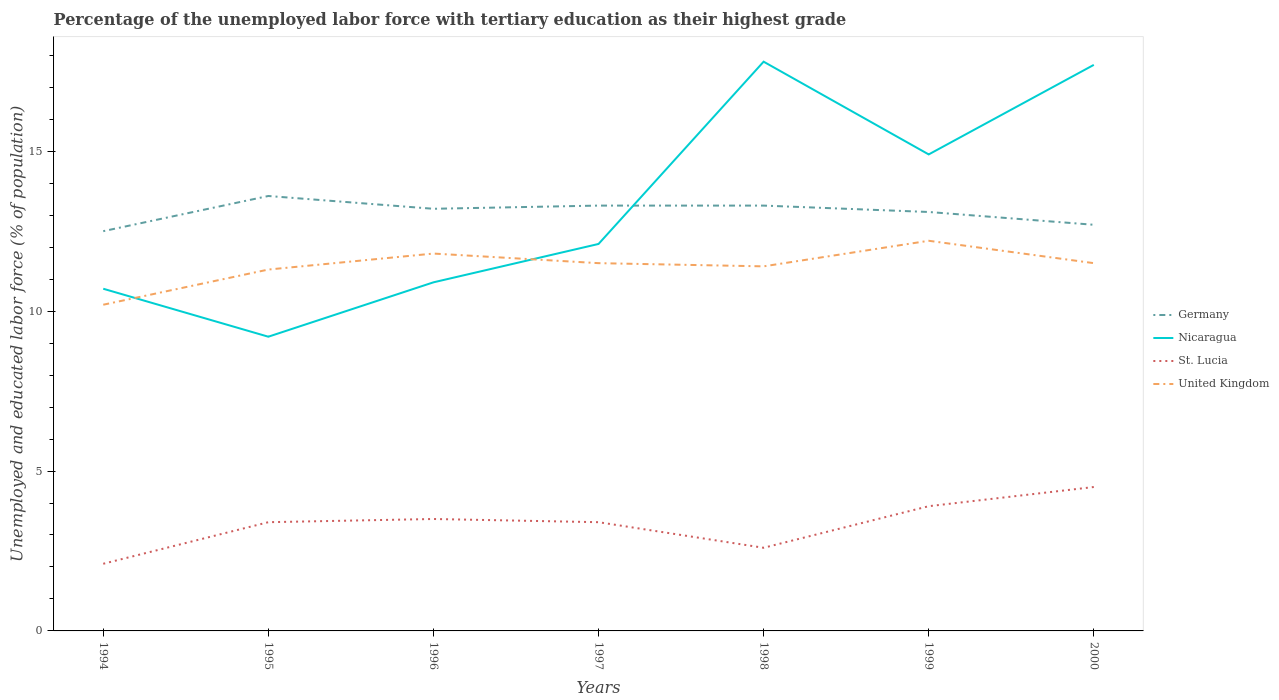Is the number of lines equal to the number of legend labels?
Your answer should be compact. Yes. Across all years, what is the maximum percentage of the unemployed labor force with tertiary education in St. Lucia?
Ensure brevity in your answer.  2.1. In which year was the percentage of the unemployed labor force with tertiary education in Germany maximum?
Your answer should be compact. 1994. What is the total percentage of the unemployed labor force with tertiary education in Nicaragua in the graph?
Give a very brief answer. -4.2. What is the difference between the highest and the second highest percentage of the unemployed labor force with tertiary education in Nicaragua?
Your response must be concise. 8.6. What is the difference between the highest and the lowest percentage of the unemployed labor force with tertiary education in St. Lucia?
Provide a succinct answer. 5. How many lines are there?
Your response must be concise. 4. What is the difference between two consecutive major ticks on the Y-axis?
Offer a very short reply. 5. Does the graph contain any zero values?
Your response must be concise. No. What is the title of the graph?
Make the answer very short. Percentage of the unemployed labor force with tertiary education as their highest grade. What is the label or title of the Y-axis?
Make the answer very short. Unemployed and educated labor force (% of population). What is the Unemployed and educated labor force (% of population) in Nicaragua in 1994?
Offer a very short reply. 10.7. What is the Unemployed and educated labor force (% of population) in St. Lucia in 1994?
Provide a succinct answer. 2.1. What is the Unemployed and educated labor force (% of population) of United Kingdom in 1994?
Provide a succinct answer. 10.2. What is the Unemployed and educated labor force (% of population) in Germany in 1995?
Keep it short and to the point. 13.6. What is the Unemployed and educated labor force (% of population) in Nicaragua in 1995?
Your response must be concise. 9.2. What is the Unemployed and educated labor force (% of population) in St. Lucia in 1995?
Make the answer very short. 3.4. What is the Unemployed and educated labor force (% of population) in United Kingdom in 1995?
Provide a succinct answer. 11.3. What is the Unemployed and educated labor force (% of population) of Germany in 1996?
Provide a succinct answer. 13.2. What is the Unemployed and educated labor force (% of population) of Nicaragua in 1996?
Your response must be concise. 10.9. What is the Unemployed and educated labor force (% of population) in United Kingdom in 1996?
Keep it short and to the point. 11.8. What is the Unemployed and educated labor force (% of population) of Germany in 1997?
Give a very brief answer. 13.3. What is the Unemployed and educated labor force (% of population) of Nicaragua in 1997?
Make the answer very short. 12.1. What is the Unemployed and educated labor force (% of population) of St. Lucia in 1997?
Your answer should be very brief. 3.4. What is the Unemployed and educated labor force (% of population) of United Kingdom in 1997?
Give a very brief answer. 11.5. What is the Unemployed and educated labor force (% of population) in Germany in 1998?
Offer a very short reply. 13.3. What is the Unemployed and educated labor force (% of population) in Nicaragua in 1998?
Provide a succinct answer. 17.8. What is the Unemployed and educated labor force (% of population) of St. Lucia in 1998?
Ensure brevity in your answer.  2.6. What is the Unemployed and educated labor force (% of population) in United Kingdom in 1998?
Ensure brevity in your answer.  11.4. What is the Unemployed and educated labor force (% of population) of Germany in 1999?
Provide a short and direct response. 13.1. What is the Unemployed and educated labor force (% of population) of Nicaragua in 1999?
Ensure brevity in your answer.  14.9. What is the Unemployed and educated labor force (% of population) in St. Lucia in 1999?
Give a very brief answer. 3.9. What is the Unemployed and educated labor force (% of population) of United Kingdom in 1999?
Your response must be concise. 12.2. What is the Unemployed and educated labor force (% of population) of Germany in 2000?
Your answer should be compact. 12.7. What is the Unemployed and educated labor force (% of population) of Nicaragua in 2000?
Offer a terse response. 17.7. What is the Unemployed and educated labor force (% of population) in St. Lucia in 2000?
Give a very brief answer. 4.5. Across all years, what is the maximum Unemployed and educated labor force (% of population) in Germany?
Your response must be concise. 13.6. Across all years, what is the maximum Unemployed and educated labor force (% of population) of Nicaragua?
Provide a succinct answer. 17.8. Across all years, what is the maximum Unemployed and educated labor force (% of population) in St. Lucia?
Ensure brevity in your answer.  4.5. Across all years, what is the maximum Unemployed and educated labor force (% of population) of United Kingdom?
Provide a succinct answer. 12.2. Across all years, what is the minimum Unemployed and educated labor force (% of population) in Germany?
Your answer should be very brief. 12.5. Across all years, what is the minimum Unemployed and educated labor force (% of population) in Nicaragua?
Make the answer very short. 9.2. Across all years, what is the minimum Unemployed and educated labor force (% of population) of St. Lucia?
Your answer should be compact. 2.1. Across all years, what is the minimum Unemployed and educated labor force (% of population) in United Kingdom?
Make the answer very short. 10.2. What is the total Unemployed and educated labor force (% of population) of Germany in the graph?
Offer a very short reply. 91.7. What is the total Unemployed and educated labor force (% of population) in Nicaragua in the graph?
Your answer should be compact. 93.3. What is the total Unemployed and educated labor force (% of population) in St. Lucia in the graph?
Ensure brevity in your answer.  23.4. What is the total Unemployed and educated labor force (% of population) of United Kingdom in the graph?
Your response must be concise. 79.9. What is the difference between the Unemployed and educated labor force (% of population) in Germany in 1994 and that in 1995?
Your answer should be very brief. -1.1. What is the difference between the Unemployed and educated labor force (% of population) of Germany in 1994 and that in 1996?
Your answer should be very brief. -0.7. What is the difference between the Unemployed and educated labor force (% of population) in St. Lucia in 1994 and that in 1996?
Your answer should be very brief. -1.4. What is the difference between the Unemployed and educated labor force (% of population) of United Kingdom in 1994 and that in 1996?
Your response must be concise. -1.6. What is the difference between the Unemployed and educated labor force (% of population) of Nicaragua in 1994 and that in 1998?
Your answer should be compact. -7.1. What is the difference between the Unemployed and educated labor force (% of population) in St. Lucia in 1994 and that in 1999?
Keep it short and to the point. -1.8. What is the difference between the Unemployed and educated labor force (% of population) of United Kingdom in 1994 and that in 1999?
Ensure brevity in your answer.  -2. What is the difference between the Unemployed and educated labor force (% of population) of Nicaragua in 1994 and that in 2000?
Give a very brief answer. -7. What is the difference between the Unemployed and educated labor force (% of population) in St. Lucia in 1994 and that in 2000?
Your answer should be compact. -2.4. What is the difference between the Unemployed and educated labor force (% of population) in Germany in 1995 and that in 1997?
Provide a succinct answer. 0.3. What is the difference between the Unemployed and educated labor force (% of population) in Nicaragua in 1995 and that in 1997?
Offer a terse response. -2.9. What is the difference between the Unemployed and educated labor force (% of population) in United Kingdom in 1995 and that in 1997?
Your response must be concise. -0.2. What is the difference between the Unemployed and educated labor force (% of population) in Nicaragua in 1995 and that in 1998?
Your answer should be very brief. -8.6. What is the difference between the Unemployed and educated labor force (% of population) of United Kingdom in 1995 and that in 1998?
Ensure brevity in your answer.  -0.1. What is the difference between the Unemployed and educated labor force (% of population) in United Kingdom in 1995 and that in 1999?
Offer a terse response. -0.9. What is the difference between the Unemployed and educated labor force (% of population) of Germany in 1995 and that in 2000?
Ensure brevity in your answer.  0.9. What is the difference between the Unemployed and educated labor force (% of population) in Nicaragua in 1995 and that in 2000?
Offer a very short reply. -8.5. What is the difference between the Unemployed and educated labor force (% of population) of St. Lucia in 1995 and that in 2000?
Your answer should be very brief. -1.1. What is the difference between the Unemployed and educated labor force (% of population) of St. Lucia in 1996 and that in 1997?
Make the answer very short. 0.1. What is the difference between the Unemployed and educated labor force (% of population) of Nicaragua in 1996 and that in 1998?
Keep it short and to the point. -6.9. What is the difference between the Unemployed and educated labor force (% of population) in United Kingdom in 1996 and that in 1998?
Provide a succinct answer. 0.4. What is the difference between the Unemployed and educated labor force (% of population) in Germany in 1996 and that in 1999?
Ensure brevity in your answer.  0.1. What is the difference between the Unemployed and educated labor force (% of population) in Nicaragua in 1996 and that in 1999?
Your response must be concise. -4. What is the difference between the Unemployed and educated labor force (% of population) of United Kingdom in 1996 and that in 1999?
Your answer should be very brief. -0.4. What is the difference between the Unemployed and educated labor force (% of population) in Germany in 1996 and that in 2000?
Provide a succinct answer. 0.5. What is the difference between the Unemployed and educated labor force (% of population) of Nicaragua in 1996 and that in 2000?
Make the answer very short. -6.8. What is the difference between the Unemployed and educated labor force (% of population) of St. Lucia in 1997 and that in 1998?
Your answer should be compact. 0.8. What is the difference between the Unemployed and educated labor force (% of population) of Germany in 1997 and that in 1999?
Your answer should be compact. 0.2. What is the difference between the Unemployed and educated labor force (% of population) of Nicaragua in 1997 and that in 1999?
Provide a succinct answer. -2.8. What is the difference between the Unemployed and educated labor force (% of population) in St. Lucia in 1997 and that in 1999?
Give a very brief answer. -0.5. What is the difference between the Unemployed and educated labor force (% of population) in Germany in 1997 and that in 2000?
Make the answer very short. 0.6. What is the difference between the Unemployed and educated labor force (% of population) of Nicaragua in 1997 and that in 2000?
Your answer should be very brief. -5.6. What is the difference between the Unemployed and educated labor force (% of population) in Nicaragua in 1998 and that in 1999?
Provide a succinct answer. 2.9. What is the difference between the Unemployed and educated labor force (% of population) in United Kingdom in 1998 and that in 1999?
Your response must be concise. -0.8. What is the difference between the Unemployed and educated labor force (% of population) in Germany in 1998 and that in 2000?
Offer a very short reply. 0.6. What is the difference between the Unemployed and educated labor force (% of population) in St. Lucia in 1998 and that in 2000?
Ensure brevity in your answer.  -1.9. What is the difference between the Unemployed and educated labor force (% of population) of Nicaragua in 1999 and that in 2000?
Your response must be concise. -2.8. What is the difference between the Unemployed and educated labor force (% of population) in St. Lucia in 1999 and that in 2000?
Offer a terse response. -0.6. What is the difference between the Unemployed and educated labor force (% of population) of United Kingdom in 1999 and that in 2000?
Your answer should be compact. 0.7. What is the difference between the Unemployed and educated labor force (% of population) in Germany in 1994 and the Unemployed and educated labor force (% of population) in Nicaragua in 1995?
Provide a succinct answer. 3.3. What is the difference between the Unemployed and educated labor force (% of population) in Germany in 1994 and the Unemployed and educated labor force (% of population) in St. Lucia in 1995?
Ensure brevity in your answer.  9.1. What is the difference between the Unemployed and educated labor force (% of population) of Nicaragua in 1994 and the Unemployed and educated labor force (% of population) of St. Lucia in 1995?
Make the answer very short. 7.3. What is the difference between the Unemployed and educated labor force (% of population) in Nicaragua in 1994 and the Unemployed and educated labor force (% of population) in United Kingdom in 1995?
Offer a terse response. -0.6. What is the difference between the Unemployed and educated labor force (% of population) in St. Lucia in 1994 and the Unemployed and educated labor force (% of population) in United Kingdom in 1995?
Ensure brevity in your answer.  -9.2. What is the difference between the Unemployed and educated labor force (% of population) of Germany in 1994 and the Unemployed and educated labor force (% of population) of Nicaragua in 1996?
Keep it short and to the point. 1.6. What is the difference between the Unemployed and educated labor force (% of population) in Germany in 1994 and the Unemployed and educated labor force (% of population) in St. Lucia in 1996?
Keep it short and to the point. 9. What is the difference between the Unemployed and educated labor force (% of population) in Nicaragua in 1994 and the Unemployed and educated labor force (% of population) in United Kingdom in 1996?
Your answer should be very brief. -1.1. What is the difference between the Unemployed and educated labor force (% of population) of Germany in 1994 and the Unemployed and educated labor force (% of population) of Nicaragua in 1997?
Provide a succinct answer. 0.4. What is the difference between the Unemployed and educated labor force (% of population) in Germany in 1994 and the Unemployed and educated labor force (% of population) in St. Lucia in 1997?
Offer a terse response. 9.1. What is the difference between the Unemployed and educated labor force (% of population) of Germany in 1994 and the Unemployed and educated labor force (% of population) of United Kingdom in 1997?
Your answer should be compact. 1. What is the difference between the Unemployed and educated labor force (% of population) of Nicaragua in 1994 and the Unemployed and educated labor force (% of population) of St. Lucia in 1997?
Your answer should be very brief. 7.3. What is the difference between the Unemployed and educated labor force (% of population) in Germany in 1994 and the Unemployed and educated labor force (% of population) in Nicaragua in 1998?
Your answer should be compact. -5.3. What is the difference between the Unemployed and educated labor force (% of population) of Germany in 1994 and the Unemployed and educated labor force (% of population) of St. Lucia in 1998?
Offer a terse response. 9.9. What is the difference between the Unemployed and educated labor force (% of population) in Nicaragua in 1994 and the Unemployed and educated labor force (% of population) in St. Lucia in 1998?
Ensure brevity in your answer.  8.1. What is the difference between the Unemployed and educated labor force (% of population) in Germany in 1994 and the Unemployed and educated labor force (% of population) in United Kingdom in 1999?
Provide a succinct answer. 0.3. What is the difference between the Unemployed and educated labor force (% of population) in Germany in 1994 and the Unemployed and educated labor force (% of population) in Nicaragua in 2000?
Your response must be concise. -5.2. What is the difference between the Unemployed and educated labor force (% of population) in Germany in 1994 and the Unemployed and educated labor force (% of population) in St. Lucia in 2000?
Ensure brevity in your answer.  8. What is the difference between the Unemployed and educated labor force (% of population) in Nicaragua in 1994 and the Unemployed and educated labor force (% of population) in St. Lucia in 2000?
Your answer should be compact. 6.2. What is the difference between the Unemployed and educated labor force (% of population) in Germany in 1995 and the Unemployed and educated labor force (% of population) in St. Lucia in 1996?
Your answer should be compact. 10.1. What is the difference between the Unemployed and educated labor force (% of population) in Germany in 1995 and the Unemployed and educated labor force (% of population) in United Kingdom in 1996?
Your response must be concise. 1.8. What is the difference between the Unemployed and educated labor force (% of population) of Nicaragua in 1995 and the Unemployed and educated labor force (% of population) of St. Lucia in 1996?
Provide a short and direct response. 5.7. What is the difference between the Unemployed and educated labor force (% of population) of Nicaragua in 1995 and the Unemployed and educated labor force (% of population) of United Kingdom in 1996?
Ensure brevity in your answer.  -2.6. What is the difference between the Unemployed and educated labor force (% of population) in Germany in 1995 and the Unemployed and educated labor force (% of population) in Nicaragua in 1997?
Keep it short and to the point. 1.5. What is the difference between the Unemployed and educated labor force (% of population) in Germany in 1995 and the Unemployed and educated labor force (% of population) in St. Lucia in 1997?
Ensure brevity in your answer.  10.2. What is the difference between the Unemployed and educated labor force (% of population) of Germany in 1995 and the Unemployed and educated labor force (% of population) of United Kingdom in 1997?
Provide a short and direct response. 2.1. What is the difference between the Unemployed and educated labor force (% of population) in Nicaragua in 1995 and the Unemployed and educated labor force (% of population) in St. Lucia in 1997?
Make the answer very short. 5.8. What is the difference between the Unemployed and educated labor force (% of population) in St. Lucia in 1995 and the Unemployed and educated labor force (% of population) in United Kingdom in 1997?
Make the answer very short. -8.1. What is the difference between the Unemployed and educated labor force (% of population) in Germany in 1995 and the Unemployed and educated labor force (% of population) in United Kingdom in 1998?
Keep it short and to the point. 2.2. What is the difference between the Unemployed and educated labor force (% of population) in Germany in 1995 and the Unemployed and educated labor force (% of population) in Nicaragua in 1999?
Offer a terse response. -1.3. What is the difference between the Unemployed and educated labor force (% of population) of Germany in 1995 and the Unemployed and educated labor force (% of population) of St. Lucia in 1999?
Your response must be concise. 9.7. What is the difference between the Unemployed and educated labor force (% of population) in Germany in 1995 and the Unemployed and educated labor force (% of population) in United Kingdom in 1999?
Your response must be concise. 1.4. What is the difference between the Unemployed and educated labor force (% of population) of Nicaragua in 1995 and the Unemployed and educated labor force (% of population) of St. Lucia in 1999?
Provide a short and direct response. 5.3. What is the difference between the Unemployed and educated labor force (% of population) of Nicaragua in 1995 and the Unemployed and educated labor force (% of population) of United Kingdom in 1999?
Give a very brief answer. -3. What is the difference between the Unemployed and educated labor force (% of population) in St. Lucia in 1995 and the Unemployed and educated labor force (% of population) in United Kingdom in 1999?
Provide a short and direct response. -8.8. What is the difference between the Unemployed and educated labor force (% of population) in Germany in 1995 and the Unemployed and educated labor force (% of population) in Nicaragua in 2000?
Provide a short and direct response. -4.1. What is the difference between the Unemployed and educated labor force (% of population) of Germany in 1995 and the Unemployed and educated labor force (% of population) of St. Lucia in 2000?
Your answer should be very brief. 9.1. What is the difference between the Unemployed and educated labor force (% of population) in Germany in 1995 and the Unemployed and educated labor force (% of population) in United Kingdom in 2000?
Provide a short and direct response. 2.1. What is the difference between the Unemployed and educated labor force (% of population) of Nicaragua in 1995 and the Unemployed and educated labor force (% of population) of St. Lucia in 2000?
Provide a succinct answer. 4.7. What is the difference between the Unemployed and educated labor force (% of population) in Nicaragua in 1995 and the Unemployed and educated labor force (% of population) in United Kingdom in 2000?
Keep it short and to the point. -2.3. What is the difference between the Unemployed and educated labor force (% of population) of St. Lucia in 1995 and the Unemployed and educated labor force (% of population) of United Kingdom in 2000?
Your answer should be very brief. -8.1. What is the difference between the Unemployed and educated labor force (% of population) of Germany in 1996 and the Unemployed and educated labor force (% of population) of United Kingdom in 1997?
Your response must be concise. 1.7. What is the difference between the Unemployed and educated labor force (% of population) of Germany in 1996 and the Unemployed and educated labor force (% of population) of Nicaragua in 1998?
Give a very brief answer. -4.6. What is the difference between the Unemployed and educated labor force (% of population) of Germany in 1996 and the Unemployed and educated labor force (% of population) of St. Lucia in 1998?
Offer a terse response. 10.6. What is the difference between the Unemployed and educated labor force (% of population) of Germany in 1996 and the Unemployed and educated labor force (% of population) of United Kingdom in 1998?
Your answer should be compact. 1.8. What is the difference between the Unemployed and educated labor force (% of population) in Nicaragua in 1996 and the Unemployed and educated labor force (% of population) in St. Lucia in 1998?
Ensure brevity in your answer.  8.3. What is the difference between the Unemployed and educated labor force (% of population) in Nicaragua in 1996 and the Unemployed and educated labor force (% of population) in United Kingdom in 1998?
Offer a terse response. -0.5. What is the difference between the Unemployed and educated labor force (% of population) of St. Lucia in 1996 and the Unemployed and educated labor force (% of population) of United Kingdom in 1998?
Offer a very short reply. -7.9. What is the difference between the Unemployed and educated labor force (% of population) in Germany in 1996 and the Unemployed and educated labor force (% of population) in St. Lucia in 1999?
Ensure brevity in your answer.  9.3. What is the difference between the Unemployed and educated labor force (% of population) of Nicaragua in 1996 and the Unemployed and educated labor force (% of population) of United Kingdom in 1999?
Offer a very short reply. -1.3. What is the difference between the Unemployed and educated labor force (% of population) in St. Lucia in 1996 and the Unemployed and educated labor force (% of population) in United Kingdom in 1999?
Make the answer very short. -8.7. What is the difference between the Unemployed and educated labor force (% of population) in Germany in 1996 and the Unemployed and educated labor force (% of population) in United Kingdom in 2000?
Your answer should be very brief. 1.7. What is the difference between the Unemployed and educated labor force (% of population) in Nicaragua in 1996 and the Unemployed and educated labor force (% of population) in St. Lucia in 2000?
Ensure brevity in your answer.  6.4. What is the difference between the Unemployed and educated labor force (% of population) in Nicaragua in 1996 and the Unemployed and educated labor force (% of population) in United Kingdom in 2000?
Give a very brief answer. -0.6. What is the difference between the Unemployed and educated labor force (% of population) of St. Lucia in 1996 and the Unemployed and educated labor force (% of population) of United Kingdom in 2000?
Provide a succinct answer. -8. What is the difference between the Unemployed and educated labor force (% of population) in Nicaragua in 1997 and the Unemployed and educated labor force (% of population) in United Kingdom in 1998?
Provide a succinct answer. 0.7. What is the difference between the Unemployed and educated labor force (% of population) in St. Lucia in 1997 and the Unemployed and educated labor force (% of population) in United Kingdom in 1998?
Provide a succinct answer. -8. What is the difference between the Unemployed and educated labor force (% of population) in Germany in 1997 and the Unemployed and educated labor force (% of population) in St. Lucia in 1999?
Your answer should be compact. 9.4. What is the difference between the Unemployed and educated labor force (% of population) of Germany in 1997 and the Unemployed and educated labor force (% of population) of United Kingdom in 1999?
Give a very brief answer. 1.1. What is the difference between the Unemployed and educated labor force (% of population) in Germany in 1997 and the Unemployed and educated labor force (% of population) in United Kingdom in 2000?
Make the answer very short. 1.8. What is the difference between the Unemployed and educated labor force (% of population) in Nicaragua in 1997 and the Unemployed and educated labor force (% of population) in United Kingdom in 2000?
Your answer should be very brief. 0.6. What is the difference between the Unemployed and educated labor force (% of population) in Germany in 1998 and the Unemployed and educated labor force (% of population) in Nicaragua in 1999?
Your response must be concise. -1.6. What is the difference between the Unemployed and educated labor force (% of population) in Germany in 1998 and the Unemployed and educated labor force (% of population) in St. Lucia in 1999?
Your answer should be compact. 9.4. What is the difference between the Unemployed and educated labor force (% of population) in Germany in 1998 and the Unemployed and educated labor force (% of population) in Nicaragua in 2000?
Ensure brevity in your answer.  -4.4. What is the difference between the Unemployed and educated labor force (% of population) of Germany in 1998 and the Unemployed and educated labor force (% of population) of St. Lucia in 2000?
Provide a succinct answer. 8.8. What is the difference between the Unemployed and educated labor force (% of population) of Nicaragua in 1998 and the Unemployed and educated labor force (% of population) of St. Lucia in 2000?
Your answer should be very brief. 13.3. What is the difference between the Unemployed and educated labor force (% of population) in St. Lucia in 1998 and the Unemployed and educated labor force (% of population) in United Kingdom in 2000?
Make the answer very short. -8.9. What is the difference between the Unemployed and educated labor force (% of population) of Germany in 1999 and the Unemployed and educated labor force (% of population) of St. Lucia in 2000?
Give a very brief answer. 8.6. What is the difference between the Unemployed and educated labor force (% of population) in St. Lucia in 1999 and the Unemployed and educated labor force (% of population) in United Kingdom in 2000?
Provide a short and direct response. -7.6. What is the average Unemployed and educated labor force (% of population) in Nicaragua per year?
Provide a short and direct response. 13.33. What is the average Unemployed and educated labor force (% of population) of St. Lucia per year?
Your answer should be compact. 3.34. What is the average Unemployed and educated labor force (% of population) in United Kingdom per year?
Your response must be concise. 11.41. In the year 1994, what is the difference between the Unemployed and educated labor force (% of population) in Germany and Unemployed and educated labor force (% of population) in Nicaragua?
Your response must be concise. 1.8. In the year 1994, what is the difference between the Unemployed and educated labor force (% of population) in Nicaragua and Unemployed and educated labor force (% of population) in St. Lucia?
Provide a short and direct response. 8.6. In the year 1994, what is the difference between the Unemployed and educated labor force (% of population) in Nicaragua and Unemployed and educated labor force (% of population) in United Kingdom?
Your response must be concise. 0.5. In the year 1994, what is the difference between the Unemployed and educated labor force (% of population) in St. Lucia and Unemployed and educated labor force (% of population) in United Kingdom?
Provide a succinct answer. -8.1. In the year 1995, what is the difference between the Unemployed and educated labor force (% of population) in Germany and Unemployed and educated labor force (% of population) in Nicaragua?
Give a very brief answer. 4.4. In the year 1995, what is the difference between the Unemployed and educated labor force (% of population) in Germany and Unemployed and educated labor force (% of population) in St. Lucia?
Provide a short and direct response. 10.2. In the year 1995, what is the difference between the Unemployed and educated labor force (% of population) of Nicaragua and Unemployed and educated labor force (% of population) of St. Lucia?
Keep it short and to the point. 5.8. In the year 1995, what is the difference between the Unemployed and educated labor force (% of population) of Nicaragua and Unemployed and educated labor force (% of population) of United Kingdom?
Provide a succinct answer. -2.1. In the year 1996, what is the difference between the Unemployed and educated labor force (% of population) in Nicaragua and Unemployed and educated labor force (% of population) in United Kingdom?
Make the answer very short. -0.9. In the year 1997, what is the difference between the Unemployed and educated labor force (% of population) of Germany and Unemployed and educated labor force (% of population) of Nicaragua?
Offer a terse response. 1.2. In the year 1997, what is the difference between the Unemployed and educated labor force (% of population) of Germany and Unemployed and educated labor force (% of population) of St. Lucia?
Your answer should be compact. 9.9. In the year 1997, what is the difference between the Unemployed and educated labor force (% of population) in Germany and Unemployed and educated labor force (% of population) in United Kingdom?
Your answer should be very brief. 1.8. In the year 1998, what is the difference between the Unemployed and educated labor force (% of population) in Germany and Unemployed and educated labor force (% of population) in St. Lucia?
Provide a succinct answer. 10.7. In the year 1998, what is the difference between the Unemployed and educated labor force (% of population) of Germany and Unemployed and educated labor force (% of population) of United Kingdom?
Give a very brief answer. 1.9. In the year 1998, what is the difference between the Unemployed and educated labor force (% of population) in Nicaragua and Unemployed and educated labor force (% of population) in United Kingdom?
Give a very brief answer. 6.4. In the year 1998, what is the difference between the Unemployed and educated labor force (% of population) in St. Lucia and Unemployed and educated labor force (% of population) in United Kingdom?
Offer a terse response. -8.8. In the year 1999, what is the difference between the Unemployed and educated labor force (% of population) of Nicaragua and Unemployed and educated labor force (% of population) of St. Lucia?
Your response must be concise. 11. In the year 1999, what is the difference between the Unemployed and educated labor force (% of population) in Nicaragua and Unemployed and educated labor force (% of population) in United Kingdom?
Provide a short and direct response. 2.7. In the year 2000, what is the difference between the Unemployed and educated labor force (% of population) in Germany and Unemployed and educated labor force (% of population) in Nicaragua?
Offer a very short reply. -5. In the year 2000, what is the difference between the Unemployed and educated labor force (% of population) of Nicaragua and Unemployed and educated labor force (% of population) of St. Lucia?
Give a very brief answer. 13.2. In the year 2000, what is the difference between the Unemployed and educated labor force (% of population) of Nicaragua and Unemployed and educated labor force (% of population) of United Kingdom?
Your response must be concise. 6.2. In the year 2000, what is the difference between the Unemployed and educated labor force (% of population) in St. Lucia and Unemployed and educated labor force (% of population) in United Kingdom?
Offer a terse response. -7. What is the ratio of the Unemployed and educated labor force (% of population) in Germany in 1994 to that in 1995?
Provide a succinct answer. 0.92. What is the ratio of the Unemployed and educated labor force (% of population) in Nicaragua in 1994 to that in 1995?
Your answer should be compact. 1.16. What is the ratio of the Unemployed and educated labor force (% of population) of St. Lucia in 1994 to that in 1995?
Keep it short and to the point. 0.62. What is the ratio of the Unemployed and educated labor force (% of population) in United Kingdom in 1994 to that in 1995?
Give a very brief answer. 0.9. What is the ratio of the Unemployed and educated labor force (% of population) of Germany in 1994 to that in 1996?
Your answer should be compact. 0.95. What is the ratio of the Unemployed and educated labor force (% of population) of Nicaragua in 1994 to that in 1996?
Ensure brevity in your answer.  0.98. What is the ratio of the Unemployed and educated labor force (% of population) in United Kingdom in 1994 to that in 1996?
Offer a very short reply. 0.86. What is the ratio of the Unemployed and educated labor force (% of population) of Germany in 1994 to that in 1997?
Provide a short and direct response. 0.94. What is the ratio of the Unemployed and educated labor force (% of population) of Nicaragua in 1994 to that in 1997?
Your answer should be compact. 0.88. What is the ratio of the Unemployed and educated labor force (% of population) of St. Lucia in 1994 to that in 1997?
Give a very brief answer. 0.62. What is the ratio of the Unemployed and educated labor force (% of population) of United Kingdom in 1994 to that in 1997?
Offer a terse response. 0.89. What is the ratio of the Unemployed and educated labor force (% of population) of Germany in 1994 to that in 1998?
Keep it short and to the point. 0.94. What is the ratio of the Unemployed and educated labor force (% of population) of Nicaragua in 1994 to that in 1998?
Offer a very short reply. 0.6. What is the ratio of the Unemployed and educated labor force (% of population) in St. Lucia in 1994 to that in 1998?
Provide a succinct answer. 0.81. What is the ratio of the Unemployed and educated labor force (% of population) of United Kingdom in 1994 to that in 1998?
Keep it short and to the point. 0.89. What is the ratio of the Unemployed and educated labor force (% of population) of Germany in 1994 to that in 1999?
Provide a short and direct response. 0.95. What is the ratio of the Unemployed and educated labor force (% of population) in Nicaragua in 1994 to that in 1999?
Provide a succinct answer. 0.72. What is the ratio of the Unemployed and educated labor force (% of population) of St. Lucia in 1994 to that in 1999?
Your response must be concise. 0.54. What is the ratio of the Unemployed and educated labor force (% of population) in United Kingdom in 1994 to that in 1999?
Your answer should be compact. 0.84. What is the ratio of the Unemployed and educated labor force (% of population) in Germany in 1994 to that in 2000?
Your answer should be very brief. 0.98. What is the ratio of the Unemployed and educated labor force (% of population) in Nicaragua in 1994 to that in 2000?
Give a very brief answer. 0.6. What is the ratio of the Unemployed and educated labor force (% of population) of St. Lucia in 1994 to that in 2000?
Provide a short and direct response. 0.47. What is the ratio of the Unemployed and educated labor force (% of population) in United Kingdom in 1994 to that in 2000?
Your response must be concise. 0.89. What is the ratio of the Unemployed and educated labor force (% of population) of Germany in 1995 to that in 1996?
Keep it short and to the point. 1.03. What is the ratio of the Unemployed and educated labor force (% of population) of Nicaragua in 1995 to that in 1996?
Make the answer very short. 0.84. What is the ratio of the Unemployed and educated labor force (% of population) in St. Lucia in 1995 to that in 1996?
Your response must be concise. 0.97. What is the ratio of the Unemployed and educated labor force (% of population) of United Kingdom in 1995 to that in 1996?
Your answer should be very brief. 0.96. What is the ratio of the Unemployed and educated labor force (% of population) in Germany in 1995 to that in 1997?
Your response must be concise. 1.02. What is the ratio of the Unemployed and educated labor force (% of population) of Nicaragua in 1995 to that in 1997?
Keep it short and to the point. 0.76. What is the ratio of the Unemployed and educated labor force (% of population) in St. Lucia in 1995 to that in 1997?
Your answer should be very brief. 1. What is the ratio of the Unemployed and educated labor force (% of population) of United Kingdom in 1995 to that in 1997?
Your answer should be compact. 0.98. What is the ratio of the Unemployed and educated labor force (% of population) of Germany in 1995 to that in 1998?
Your answer should be very brief. 1.02. What is the ratio of the Unemployed and educated labor force (% of population) of Nicaragua in 1995 to that in 1998?
Your answer should be compact. 0.52. What is the ratio of the Unemployed and educated labor force (% of population) of St. Lucia in 1995 to that in 1998?
Make the answer very short. 1.31. What is the ratio of the Unemployed and educated labor force (% of population) of Germany in 1995 to that in 1999?
Give a very brief answer. 1.04. What is the ratio of the Unemployed and educated labor force (% of population) of Nicaragua in 1995 to that in 1999?
Your answer should be compact. 0.62. What is the ratio of the Unemployed and educated labor force (% of population) of St. Lucia in 1995 to that in 1999?
Ensure brevity in your answer.  0.87. What is the ratio of the Unemployed and educated labor force (% of population) of United Kingdom in 1995 to that in 1999?
Make the answer very short. 0.93. What is the ratio of the Unemployed and educated labor force (% of population) in Germany in 1995 to that in 2000?
Ensure brevity in your answer.  1.07. What is the ratio of the Unemployed and educated labor force (% of population) in Nicaragua in 1995 to that in 2000?
Offer a very short reply. 0.52. What is the ratio of the Unemployed and educated labor force (% of population) in St. Lucia in 1995 to that in 2000?
Provide a succinct answer. 0.76. What is the ratio of the Unemployed and educated labor force (% of population) of United Kingdom in 1995 to that in 2000?
Give a very brief answer. 0.98. What is the ratio of the Unemployed and educated labor force (% of population) of Nicaragua in 1996 to that in 1997?
Provide a succinct answer. 0.9. What is the ratio of the Unemployed and educated labor force (% of population) in St. Lucia in 1996 to that in 1997?
Your answer should be very brief. 1.03. What is the ratio of the Unemployed and educated labor force (% of population) of United Kingdom in 1996 to that in 1997?
Make the answer very short. 1.03. What is the ratio of the Unemployed and educated labor force (% of population) of Germany in 1996 to that in 1998?
Give a very brief answer. 0.99. What is the ratio of the Unemployed and educated labor force (% of population) of Nicaragua in 1996 to that in 1998?
Your answer should be compact. 0.61. What is the ratio of the Unemployed and educated labor force (% of population) of St. Lucia in 1996 to that in 1998?
Offer a terse response. 1.35. What is the ratio of the Unemployed and educated labor force (% of population) of United Kingdom in 1996 to that in 1998?
Your answer should be compact. 1.04. What is the ratio of the Unemployed and educated labor force (% of population) of Germany in 1996 to that in 1999?
Provide a short and direct response. 1.01. What is the ratio of the Unemployed and educated labor force (% of population) of Nicaragua in 1996 to that in 1999?
Your response must be concise. 0.73. What is the ratio of the Unemployed and educated labor force (% of population) of St. Lucia in 1996 to that in 1999?
Offer a terse response. 0.9. What is the ratio of the Unemployed and educated labor force (% of population) of United Kingdom in 1996 to that in 1999?
Give a very brief answer. 0.97. What is the ratio of the Unemployed and educated labor force (% of population) in Germany in 1996 to that in 2000?
Ensure brevity in your answer.  1.04. What is the ratio of the Unemployed and educated labor force (% of population) in Nicaragua in 1996 to that in 2000?
Your answer should be very brief. 0.62. What is the ratio of the Unemployed and educated labor force (% of population) of St. Lucia in 1996 to that in 2000?
Provide a succinct answer. 0.78. What is the ratio of the Unemployed and educated labor force (% of population) of United Kingdom in 1996 to that in 2000?
Give a very brief answer. 1.03. What is the ratio of the Unemployed and educated labor force (% of population) in Germany in 1997 to that in 1998?
Offer a very short reply. 1. What is the ratio of the Unemployed and educated labor force (% of population) of Nicaragua in 1997 to that in 1998?
Provide a short and direct response. 0.68. What is the ratio of the Unemployed and educated labor force (% of population) of St. Lucia in 1997 to that in 1998?
Your response must be concise. 1.31. What is the ratio of the Unemployed and educated labor force (% of population) of United Kingdom in 1997 to that in 1998?
Your answer should be very brief. 1.01. What is the ratio of the Unemployed and educated labor force (% of population) in Germany in 1997 to that in 1999?
Make the answer very short. 1.02. What is the ratio of the Unemployed and educated labor force (% of population) of Nicaragua in 1997 to that in 1999?
Ensure brevity in your answer.  0.81. What is the ratio of the Unemployed and educated labor force (% of population) of St. Lucia in 1997 to that in 1999?
Make the answer very short. 0.87. What is the ratio of the Unemployed and educated labor force (% of population) in United Kingdom in 1997 to that in 1999?
Your answer should be compact. 0.94. What is the ratio of the Unemployed and educated labor force (% of population) of Germany in 1997 to that in 2000?
Your answer should be compact. 1.05. What is the ratio of the Unemployed and educated labor force (% of population) in Nicaragua in 1997 to that in 2000?
Offer a very short reply. 0.68. What is the ratio of the Unemployed and educated labor force (% of population) of St. Lucia in 1997 to that in 2000?
Provide a short and direct response. 0.76. What is the ratio of the Unemployed and educated labor force (% of population) in Germany in 1998 to that in 1999?
Give a very brief answer. 1.02. What is the ratio of the Unemployed and educated labor force (% of population) of Nicaragua in 1998 to that in 1999?
Keep it short and to the point. 1.19. What is the ratio of the Unemployed and educated labor force (% of population) in United Kingdom in 1998 to that in 1999?
Give a very brief answer. 0.93. What is the ratio of the Unemployed and educated labor force (% of population) in Germany in 1998 to that in 2000?
Your answer should be compact. 1.05. What is the ratio of the Unemployed and educated labor force (% of population) in Nicaragua in 1998 to that in 2000?
Provide a short and direct response. 1.01. What is the ratio of the Unemployed and educated labor force (% of population) in St. Lucia in 1998 to that in 2000?
Your response must be concise. 0.58. What is the ratio of the Unemployed and educated labor force (% of population) of Germany in 1999 to that in 2000?
Make the answer very short. 1.03. What is the ratio of the Unemployed and educated labor force (% of population) of Nicaragua in 1999 to that in 2000?
Provide a short and direct response. 0.84. What is the ratio of the Unemployed and educated labor force (% of population) of St. Lucia in 1999 to that in 2000?
Provide a short and direct response. 0.87. What is the ratio of the Unemployed and educated labor force (% of population) of United Kingdom in 1999 to that in 2000?
Offer a terse response. 1.06. What is the difference between the highest and the second highest Unemployed and educated labor force (% of population) of Germany?
Offer a terse response. 0.3. What is the difference between the highest and the second highest Unemployed and educated labor force (% of population) in Nicaragua?
Offer a very short reply. 0.1. What is the difference between the highest and the lowest Unemployed and educated labor force (% of population) in Germany?
Offer a very short reply. 1.1. What is the difference between the highest and the lowest Unemployed and educated labor force (% of population) in Nicaragua?
Provide a succinct answer. 8.6. What is the difference between the highest and the lowest Unemployed and educated labor force (% of population) of United Kingdom?
Your answer should be compact. 2. 